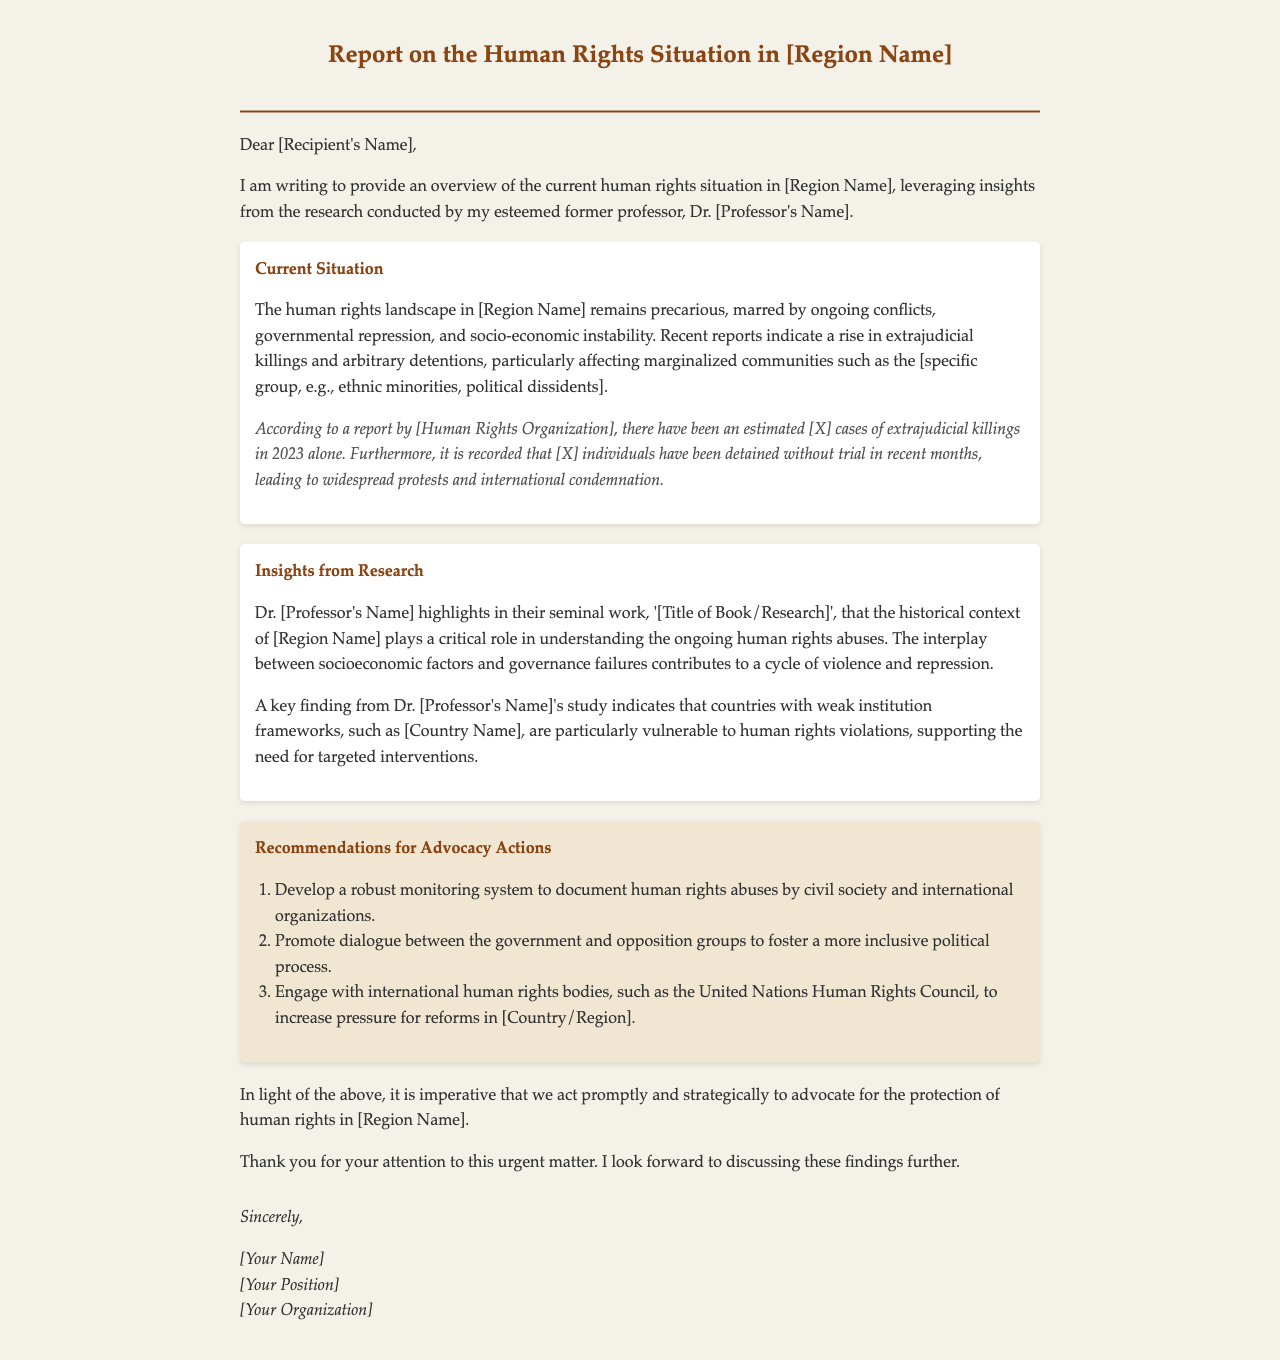What is the title of the report? The title of the report is mentioned in the letterhead of the document.
Answer: Report on the Human Rights Situation in [Region Name] Who authored the research insights in the report? The insights in the report are attributed to the author's former professor.
Answer: Dr. [Professor's Name] What year saw the reported cases of extrajudicial killings? The document states the reported cases occurred specifically in one year.
Answer: 2023 What aspect of the situation is increasing according to the report? The report indicates that a particular type of human rights violation is on the rise.
Answer: Extrajudicial killings What weak institution is highlighted in the insights? The insights point out a specific country with weak institutional frameworks related to human rights issues.
Answer: [Country Name] How many recommendations are provided for advocacy actions? The section on advocacy actions includes a list that indicates the number of recommendations.
Answer: Three What specific groups are mentioned as being affected by human rights violations? The report identifies particular marginalized communities within the region that are suffering.
Answer: [specific group, e.g., ethnic minorities, political dissidents] What is the main purpose of the letter? The letter's objective is to present a specific overview related to a critical issue in the document.
Answer: Provide an overview of the current human rights situation 